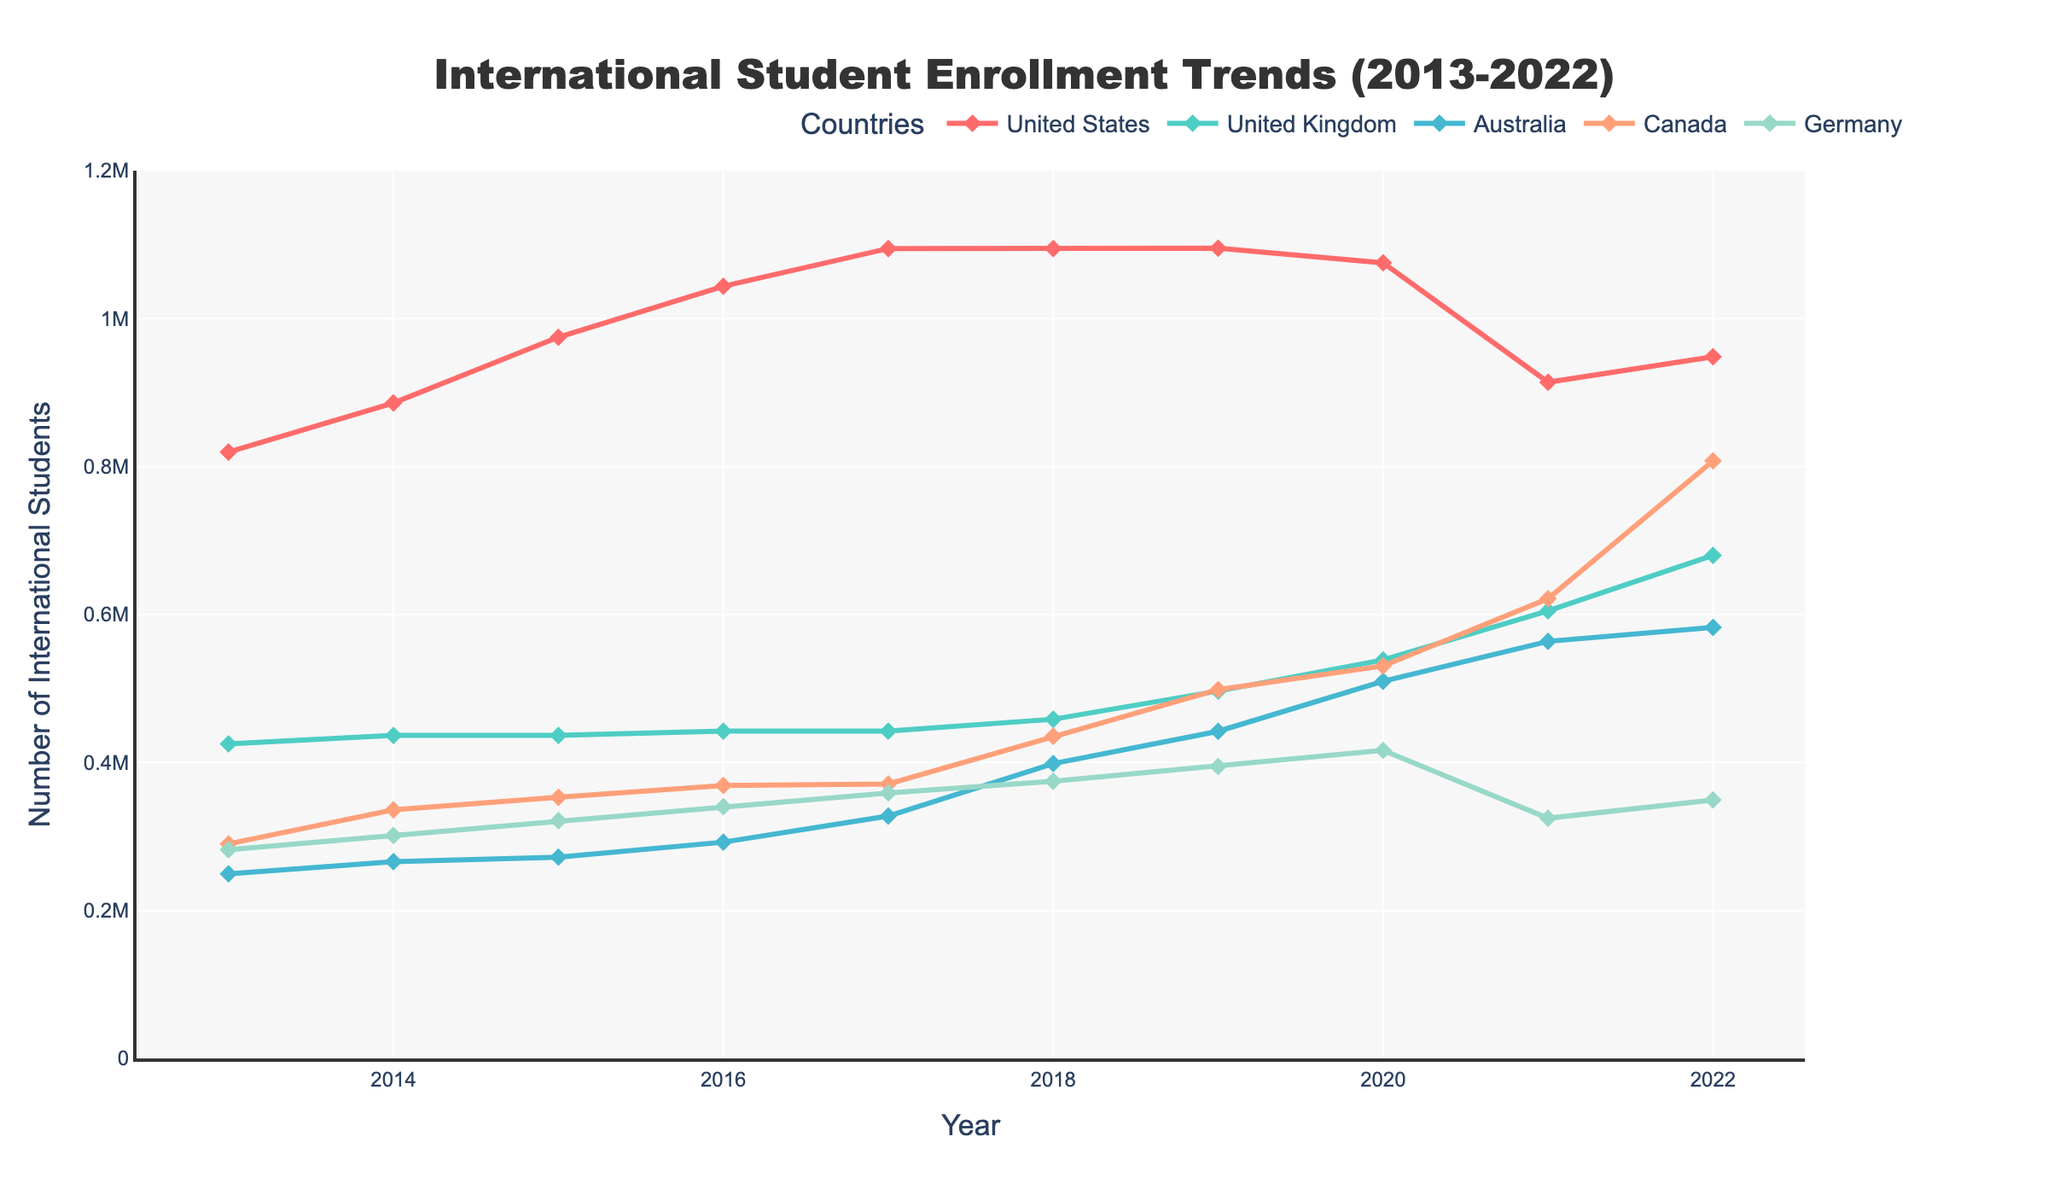Which country had the highest international student enrollment in 2019? In 2019, looking at the figures for each country, the United States had the highest number of international students, as the line representing the United States is the highest on the graph for that year.
Answer: The United States What is the trend of international student enrollment in Germany from 2013 to 2022? Observing the line representing Germany from 2013 to 2022, it shows a generally increasing trend but with a noticeable dip in 2021 followed by a recovery in 2022.
Answer: Generally increasing with a dip in 2021 and recovery in 2022 How did international student enrollment in Canada and Australia change between 2020 and 2022? For Canada, the enrollment increased from 530,540 in 2020 to 807,750 in 2022. For Australia, the enrollment increased from 509,766 in 2020 to 582,630 in 2022. Both countries show increasing trends.
Answer: Both increased Which two countries had the closest number of international students in 2016? By comparing the data points for all countries in 2016, it is observed that Canada (369,000) and Germany (340,305) had the closest numbers of international students.
Answer: Canada and Germany What is the average international student enrollment in the United Kingdom from 2013 to 2022? To calculate the average, sum all enrollments from 2013 to 2022 (425,265 + 436,585 + 436,585 + 442,375 + 442,375 + 458,490 + 496,570 + 538,615 + 605,130 + 679,970 = 4,961,960), then divide by 10 (years), resulting in 496,196.
Answer: 496,196 By how much did the number of international students in the United States decrease from 2019 to 2021? From the graph, the number decreased from 1,095,299 in 2019 to 914,095 in 2021. The difference is 1,095,299 - 914,095 = 181,204.
Answer: 181,204 Which country saw the most significant increase in international student enrollment between 2013 and 2022? By comparing the differences in student enrollments over the years for all countries, the United Kingdom saw the most significant increase from 425,265 in 2013 to 679,970 in 2022, an increase of (679,970 - 425,265 = 254,705).
Answer: The United Kingdom What is the color used for the line representing Australia in the chart? The chart uses a distinctive color palette, and Australia is represented with a blue line.
Answer: Blue In which year did the United States reach its peak international student enrollment between 2013 and 2022? Observing the highest point on the line representing the United States, 2019 shows the peak enrollment with 1,095,299 students.
Answer: 2019 